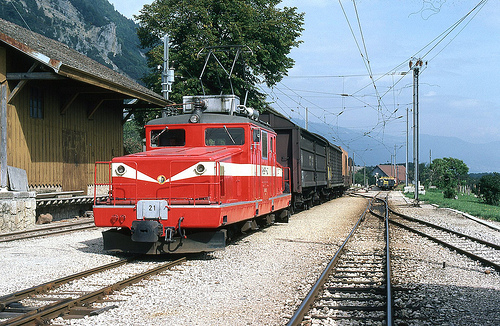Which color are the clouds? The clouds in the sky above are a pristine white, suggesting a clear, pleasant day. 